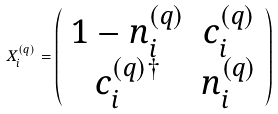<formula> <loc_0><loc_0><loc_500><loc_500>X ^ { ( q ) } _ { i } = \left ( \begin{array} { c c } 1 - n _ { i } ^ { ( q ) } & c _ { i } ^ { ( q ) } \\ c _ { i } ^ { ( q ) \dagger } & n _ { i } ^ { ( q ) } \\ \end{array} \right )</formula> 